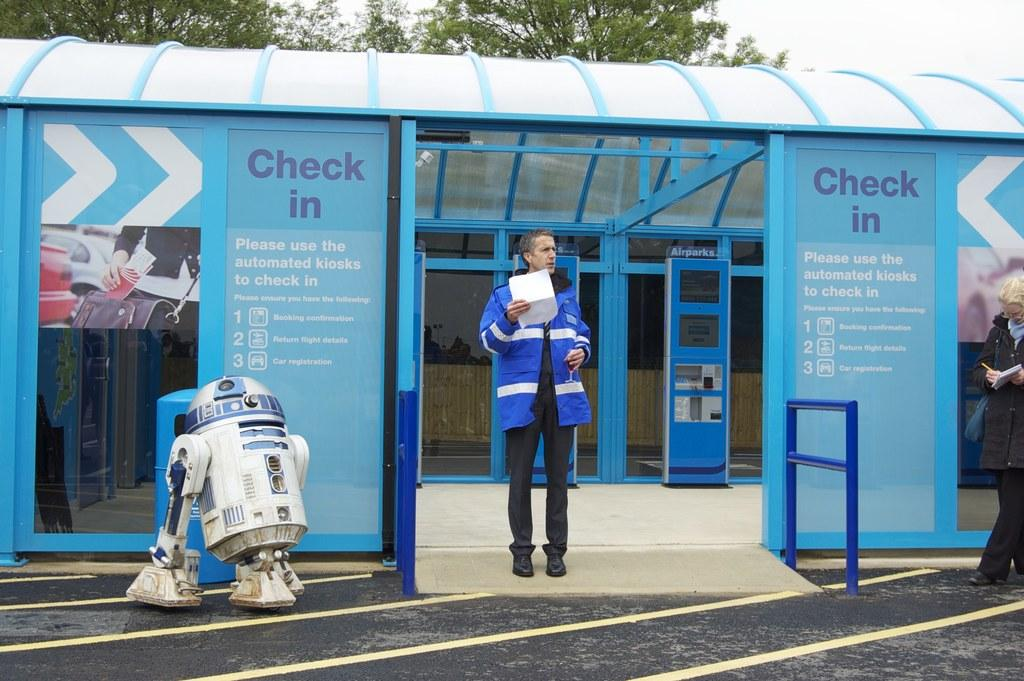What is located in the foreground of the picture? In the foreground of the picture, there is a robot, hand railing, a woman, a man, another robot, and posters. Can you describe the people in the foreground of the picture? There is a woman and a man in the foreground of the picture. What type of structure can be seen in the background of the picture? There is a building in the background of the picture. What else can be seen in the background of the picture? In the background of the picture, there are trees and sky visible. What type of boys can be seen eating popcorn in the image? There are no boys or popcorn present in the image. What kind of shoe is the robot wearing in the image? Robots do not wear shoes, as they are not human and do not have feet. 